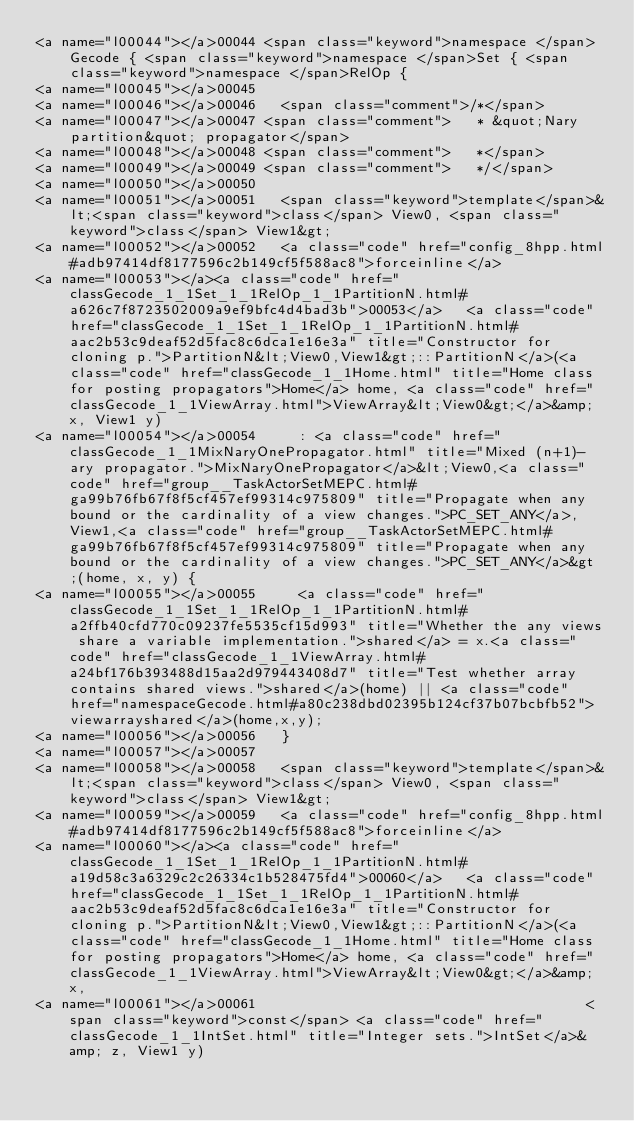<code> <loc_0><loc_0><loc_500><loc_500><_HTML_><a name="l00044"></a>00044 <span class="keyword">namespace </span>Gecode { <span class="keyword">namespace </span>Set { <span class="keyword">namespace </span>RelOp {
<a name="l00045"></a>00045 
<a name="l00046"></a>00046   <span class="comment">/*</span>
<a name="l00047"></a>00047 <span class="comment">   * &quot;Nary partition&quot; propagator</span>
<a name="l00048"></a>00048 <span class="comment">   *</span>
<a name="l00049"></a>00049 <span class="comment">   */</span>
<a name="l00050"></a>00050 
<a name="l00051"></a>00051   <span class="keyword">template</span>&lt;<span class="keyword">class</span> View0, <span class="keyword">class</span> View1&gt;
<a name="l00052"></a>00052   <a class="code" href="config_8hpp.html#adb97414df8177596c2b149cf5f588ac8">forceinline</a>
<a name="l00053"></a><a class="code" href="classGecode_1_1Set_1_1RelOp_1_1PartitionN.html#a626c7f8723502009a9ef9bfc4d4bad3b">00053</a>   <a class="code" href="classGecode_1_1Set_1_1RelOp_1_1PartitionN.html#aac2b53c9deaf52d5fac8c6dca1e16e3a" title="Constructor for cloning p.">PartitionN&lt;View0,View1&gt;::PartitionN</a>(<a class="code" href="classGecode_1_1Home.html" title="Home class for posting propagators">Home</a> home, <a class="code" href="classGecode_1_1ViewArray.html">ViewArray&lt;View0&gt;</a>&amp; x, View1 y)
<a name="l00054"></a>00054     : <a class="code" href="classGecode_1_1MixNaryOnePropagator.html" title="Mixed (n+1)-ary propagator.">MixNaryOnePropagator</a>&lt;View0,<a class="code" href="group__TaskActorSetMEPC.html#ga99b76fb67f8f5cf457ef99314c975809" title="Propagate when any bound or the cardinality of a view changes.">PC_SET_ANY</a>,View1,<a class="code" href="group__TaskActorSetMEPC.html#ga99b76fb67f8f5cf457ef99314c975809" title="Propagate when any bound or the cardinality of a view changes.">PC_SET_ANY</a>&gt;(home, x, y) {
<a name="l00055"></a>00055     <a class="code" href="classGecode_1_1Set_1_1RelOp_1_1PartitionN.html#a2ffb40cfd770c09237fe5535cf15d993" title="Whether the any views share a variable implementation.">shared</a> = x.<a class="code" href="classGecode_1_1ViewArray.html#a24bf176b393488d15aa2d979443408d7" title="Test whether array contains shared views.">shared</a>(home) || <a class="code" href="namespaceGecode.html#a80c238dbd02395b124cf37b07bcbfb52">viewarrayshared</a>(home,x,y);
<a name="l00056"></a>00056   }
<a name="l00057"></a>00057 
<a name="l00058"></a>00058   <span class="keyword">template</span>&lt;<span class="keyword">class</span> View0, <span class="keyword">class</span> View1&gt;
<a name="l00059"></a>00059   <a class="code" href="config_8hpp.html#adb97414df8177596c2b149cf5f588ac8">forceinline</a>
<a name="l00060"></a><a class="code" href="classGecode_1_1Set_1_1RelOp_1_1PartitionN.html#a19d58c3a6329c2c26334c1b528475fd4">00060</a>   <a class="code" href="classGecode_1_1Set_1_1RelOp_1_1PartitionN.html#aac2b53c9deaf52d5fac8c6dca1e16e3a" title="Constructor for cloning p.">PartitionN&lt;View0,View1&gt;::PartitionN</a>(<a class="code" href="classGecode_1_1Home.html" title="Home class for posting propagators">Home</a> home, <a class="code" href="classGecode_1_1ViewArray.html">ViewArray&lt;View0&gt;</a>&amp; x,
<a name="l00061"></a>00061                                       <span class="keyword">const</span> <a class="code" href="classGecode_1_1IntSet.html" title="Integer sets.">IntSet</a>&amp; z, View1 y)</code> 